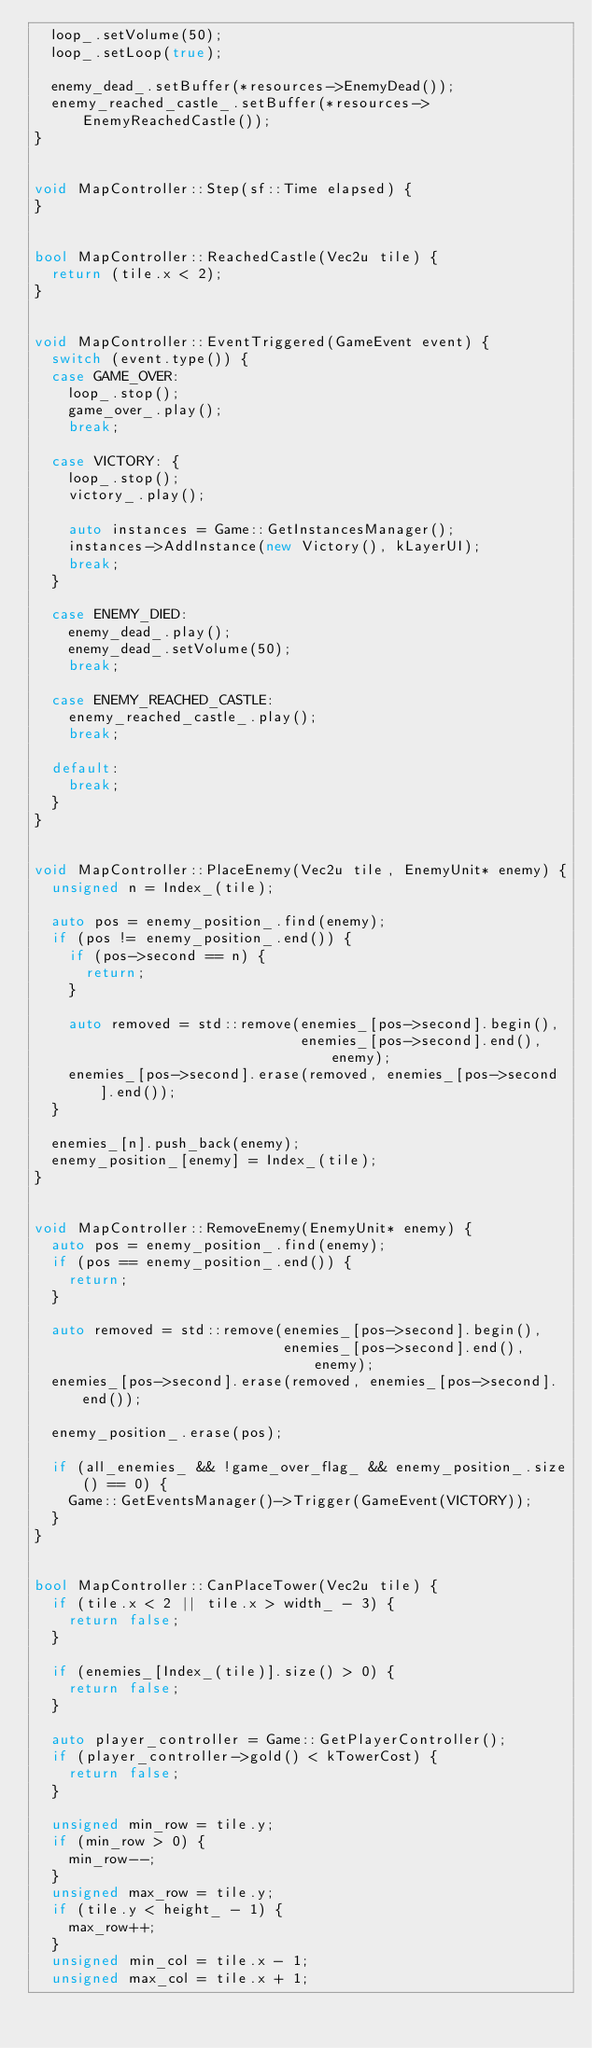Convert code to text. <code><loc_0><loc_0><loc_500><loc_500><_C++_>  loop_.setVolume(50);
  loop_.setLoop(true);

  enemy_dead_.setBuffer(*resources->EnemyDead());
  enemy_reached_castle_.setBuffer(*resources->EnemyReachedCastle());
}


void MapController::Step(sf::Time elapsed) {
}


bool MapController::ReachedCastle(Vec2u tile) {
  return (tile.x < 2);
}


void MapController::EventTriggered(GameEvent event) {
  switch (event.type()) {
  case GAME_OVER:
    loop_.stop();
    game_over_.play();
    break;

  case VICTORY: {
    loop_.stop();
    victory_.play();

    auto instances = Game::GetInstancesManager();
    instances->AddInstance(new Victory(), kLayerUI);
    break;
  }

  case ENEMY_DIED:
    enemy_dead_.play();
    enemy_dead_.setVolume(50);
    break;

  case ENEMY_REACHED_CASTLE:
    enemy_reached_castle_.play();
    break;

  default:
    break;
  }
}


void MapController::PlaceEnemy(Vec2u tile, EnemyUnit* enemy) {
  unsigned n = Index_(tile);

  auto pos = enemy_position_.find(enemy);
  if (pos != enemy_position_.end()) {
    if (pos->second == n) {
      return;
    }

    auto removed = std::remove(enemies_[pos->second].begin(),
                               enemies_[pos->second].end(), enemy);
    enemies_[pos->second].erase(removed, enemies_[pos->second].end());
  }

  enemies_[n].push_back(enemy);
  enemy_position_[enemy] = Index_(tile);
}


void MapController::RemoveEnemy(EnemyUnit* enemy) {
  auto pos = enemy_position_.find(enemy);
  if (pos == enemy_position_.end()) {
    return;
  }

  auto removed = std::remove(enemies_[pos->second].begin(),
                             enemies_[pos->second].end(), enemy);
  enemies_[pos->second].erase(removed, enemies_[pos->second].end());

  enemy_position_.erase(pos);

  if (all_enemies_ && !game_over_flag_ && enemy_position_.size() == 0) {
    Game::GetEventsManager()->Trigger(GameEvent(VICTORY));
  }
}


bool MapController::CanPlaceTower(Vec2u tile) {
  if (tile.x < 2 || tile.x > width_ - 3) {
    return false;
  }

  if (enemies_[Index_(tile)].size() > 0) {
    return false;
  }

  auto player_controller = Game::GetPlayerController();
  if (player_controller->gold() < kTowerCost) {
    return false;
  }

  unsigned min_row = tile.y;
  if (min_row > 0) {
    min_row--;
  }
  unsigned max_row = tile.y;
  if (tile.y < height_ - 1) {
    max_row++;
  }
  unsigned min_col = tile.x - 1;
  unsigned max_col = tile.x + 1;
</code> 